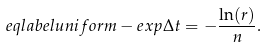<formula> <loc_0><loc_0><loc_500><loc_500>\ e q l a b e l { u n i f o r m - e x p } \Delta t = - \frac { \ln ( r ) } { n } .</formula> 